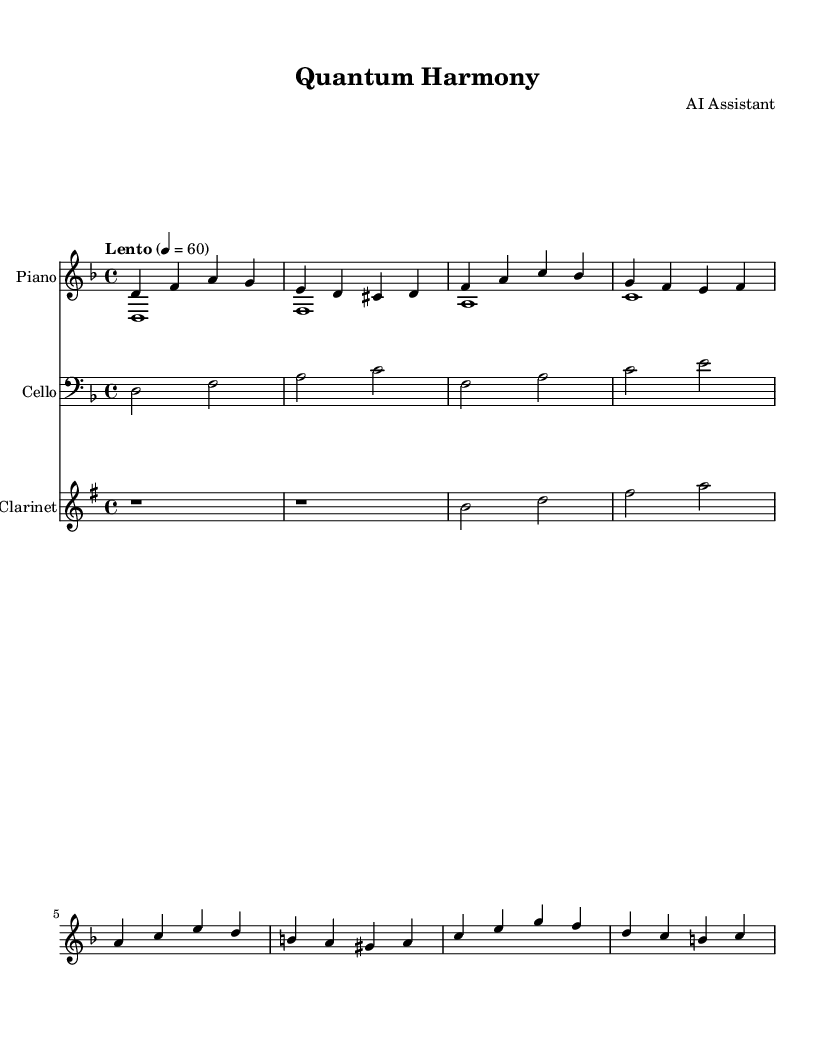What is the key signature of this music? The key signature is indicated at the beginning of the score. In this case, it shows two flats, indicating that it is in D minor, which has one flat.
Answer: D minor What is the time signature of the piece? The time signature is found at the beginning of the score next to the key signature. It shows a "4/4" time signature, meaning there are four beats per measure.
Answer: 4/4 What does the tempo marking indicate? The tempo marking is located above the staff and describes the speed of the piece. Here it shows "Lento" with a metronome marking of 60, indicating a slow tempo.
Answer: Lento, 60 How many measures are in the right-hand part? To find this, count the number of separated groups of notes or bar lines in the right-hand part. The right-hand part contains 8 measures.
Answer: 8 What is the name of the instrument for the second staff? The second staff is labeled with the instrument's name. It specifies "Cello," indicating the instrument that plays the notes written in that staff.
Answer: Cello What is the highest pitch note in the clarinet part? Examine the clarinet part to identify the notes being played. The highest note in this part is "G," which can be seen in the second measure.
Answer: G What type of music is this piece considered to be? Given the title "Quantum Harmony" and the meditative nature of the piece, it is categorized as a meditative hymn designed for religious or contemplative settings.
Answer: Meditative hymn 